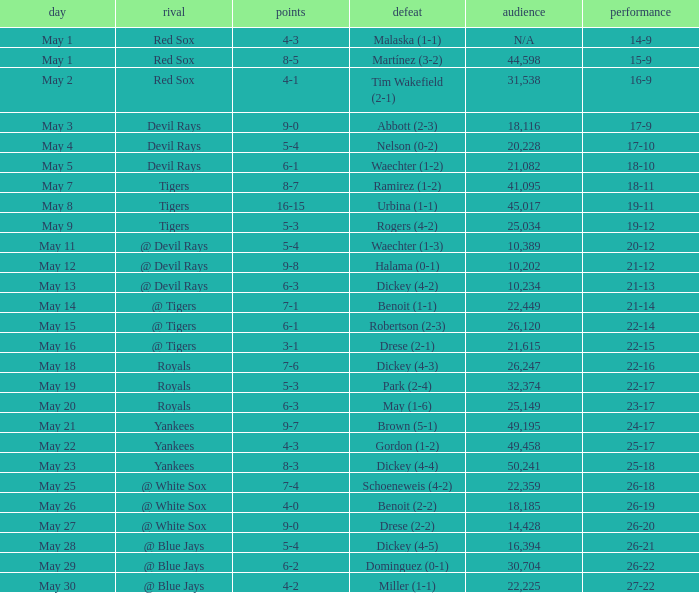What was the result of the game that had 10,389 spectators? 20-12. 